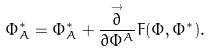<formula> <loc_0><loc_0><loc_500><loc_500>\Phi _ { A } ^ { * } = \Phi _ { A } ^ { * } + \frac { \stackrel { \rightarrow } { \partial } } { \partial \Phi ^ { A } } F ( \Phi , \Phi ^ { * } ) .</formula> 